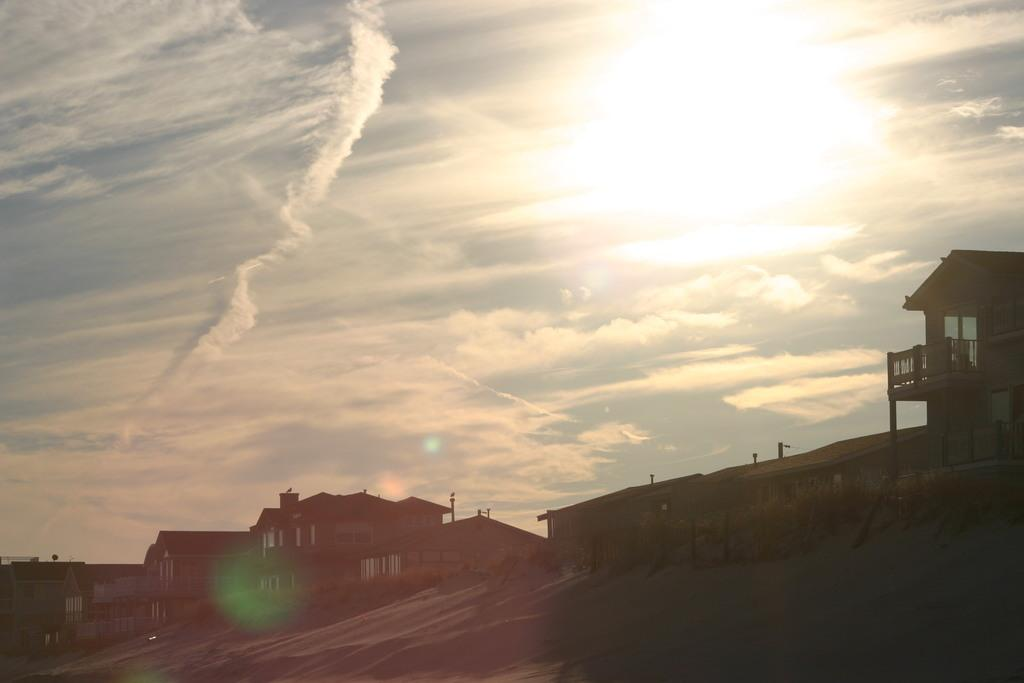What type of structures can be seen in the image? There are buildings in the image. What feature is visible on the buildings? There are windows visible in the image. What else can be seen in the image besides buildings? There are poles in the image. What is visible in the background of the image? The sky is visible in the background of the image. What can be observed in the sky? Clouds are present in the sky. What type of insect can be seen crawling on the box in the image? There is no insect or box present in the image; it only features buildings, windows, poles, and the sky with clouds. 